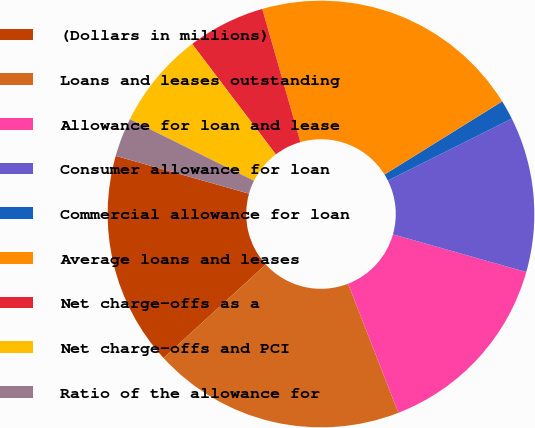<chart> <loc_0><loc_0><loc_500><loc_500><pie_chart><fcel>(Dollars in millions)<fcel>Loans and leases outstanding<fcel>Allowance for loan and lease<fcel>Consumer allowance for loan<fcel>Commercial allowance for loan<fcel>Average loans and leases<fcel>Net charge-offs as a<fcel>Net charge-offs and PCI<fcel>Ratio of the allowance for<nl><fcel>16.18%<fcel>19.12%<fcel>14.71%<fcel>11.76%<fcel>1.47%<fcel>20.59%<fcel>5.88%<fcel>7.35%<fcel>2.94%<nl></chart> 